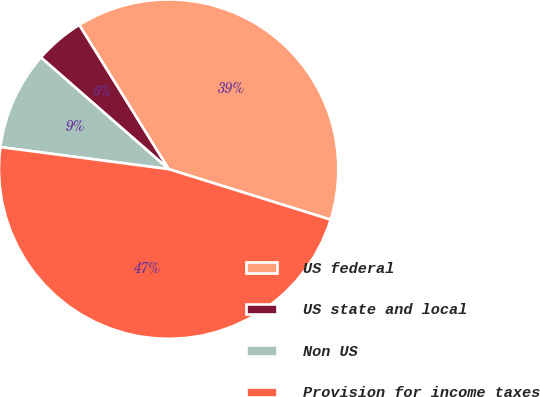Convert chart to OTSL. <chart><loc_0><loc_0><loc_500><loc_500><pie_chart><fcel>US federal<fcel>US state and local<fcel>Non US<fcel>Provision for income taxes<nl><fcel>38.65%<fcel>4.73%<fcel>9.36%<fcel>47.26%<nl></chart> 